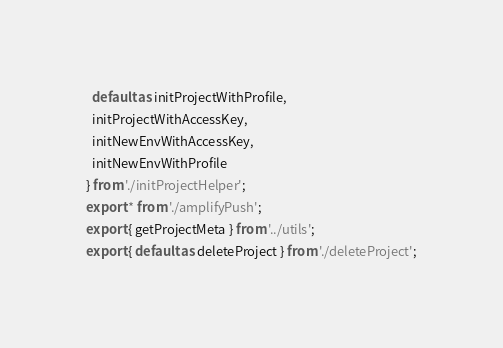Convert code to text. <code><loc_0><loc_0><loc_500><loc_500><_TypeScript_>  default as initProjectWithProfile,
  initProjectWithAccessKey,
  initNewEnvWithAccessKey,
  initNewEnvWithProfile
} from './initProjectHelper';
export * from './amplifyPush';
export { getProjectMeta } from '../utils';
export { default as deleteProject } from './deleteProject';
</code> 